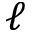Convert formula to latex. <formula><loc_0><loc_0><loc_500><loc_500>\ell</formula> 